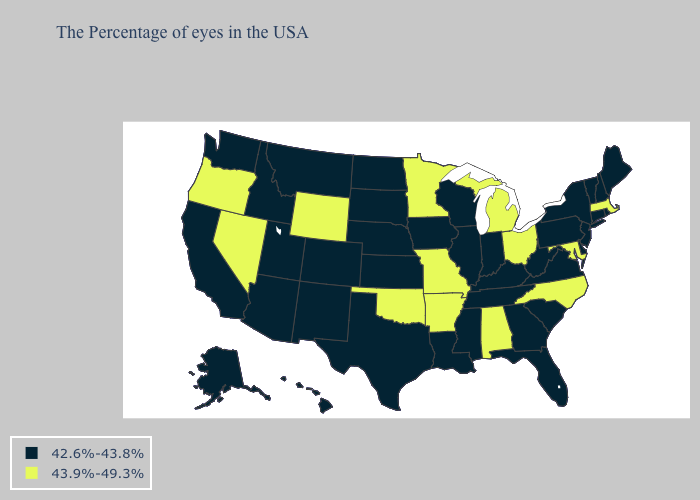What is the highest value in the USA?
Answer briefly. 43.9%-49.3%. Does Minnesota have the same value as Colorado?
Keep it brief. No. Name the states that have a value in the range 43.9%-49.3%?
Be succinct. Massachusetts, Maryland, North Carolina, Ohio, Michigan, Alabama, Missouri, Arkansas, Minnesota, Oklahoma, Wyoming, Nevada, Oregon. How many symbols are there in the legend?
Give a very brief answer. 2. Which states have the highest value in the USA?
Give a very brief answer. Massachusetts, Maryland, North Carolina, Ohio, Michigan, Alabama, Missouri, Arkansas, Minnesota, Oklahoma, Wyoming, Nevada, Oregon. What is the highest value in the Northeast ?
Keep it brief. 43.9%-49.3%. Name the states that have a value in the range 42.6%-43.8%?
Short answer required. Maine, Rhode Island, New Hampshire, Vermont, Connecticut, New York, New Jersey, Delaware, Pennsylvania, Virginia, South Carolina, West Virginia, Florida, Georgia, Kentucky, Indiana, Tennessee, Wisconsin, Illinois, Mississippi, Louisiana, Iowa, Kansas, Nebraska, Texas, South Dakota, North Dakota, Colorado, New Mexico, Utah, Montana, Arizona, Idaho, California, Washington, Alaska, Hawaii. What is the lowest value in the USA?
Give a very brief answer. 42.6%-43.8%. Does Delaware have a lower value than Alabama?
Concise answer only. Yes. Name the states that have a value in the range 42.6%-43.8%?
Be succinct. Maine, Rhode Island, New Hampshire, Vermont, Connecticut, New York, New Jersey, Delaware, Pennsylvania, Virginia, South Carolina, West Virginia, Florida, Georgia, Kentucky, Indiana, Tennessee, Wisconsin, Illinois, Mississippi, Louisiana, Iowa, Kansas, Nebraska, Texas, South Dakota, North Dakota, Colorado, New Mexico, Utah, Montana, Arizona, Idaho, California, Washington, Alaska, Hawaii. Name the states that have a value in the range 43.9%-49.3%?
Answer briefly. Massachusetts, Maryland, North Carolina, Ohio, Michigan, Alabama, Missouri, Arkansas, Minnesota, Oklahoma, Wyoming, Nevada, Oregon. Does Ohio have the highest value in the MidWest?
Write a very short answer. Yes. What is the value of North Carolina?
Concise answer only. 43.9%-49.3%. Among the states that border Idaho , does Nevada have the highest value?
Short answer required. Yes. Among the states that border Colorado , which have the lowest value?
Be succinct. Kansas, Nebraska, New Mexico, Utah, Arizona. 